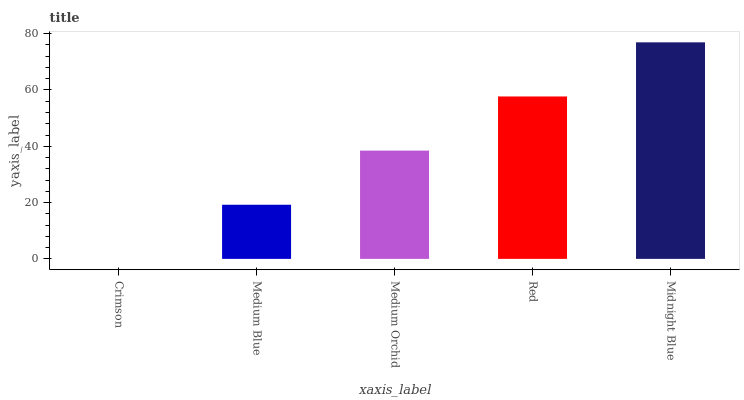Is Crimson the minimum?
Answer yes or no. Yes. Is Midnight Blue the maximum?
Answer yes or no. Yes. Is Medium Blue the minimum?
Answer yes or no. No. Is Medium Blue the maximum?
Answer yes or no. No. Is Medium Blue greater than Crimson?
Answer yes or no. Yes. Is Crimson less than Medium Blue?
Answer yes or no. Yes. Is Crimson greater than Medium Blue?
Answer yes or no. No. Is Medium Blue less than Crimson?
Answer yes or no. No. Is Medium Orchid the high median?
Answer yes or no. Yes. Is Medium Orchid the low median?
Answer yes or no. Yes. Is Medium Blue the high median?
Answer yes or no. No. Is Crimson the low median?
Answer yes or no. No. 